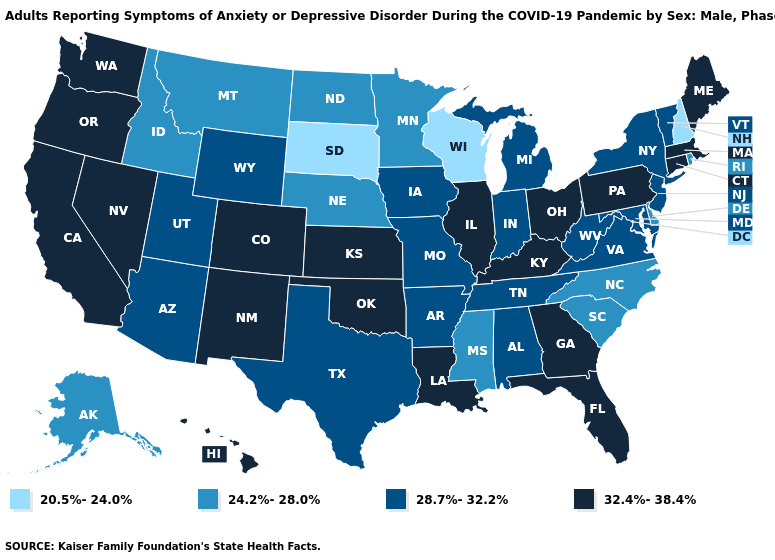Name the states that have a value in the range 20.5%-24.0%?
Short answer required. New Hampshire, South Dakota, Wisconsin. Is the legend a continuous bar?
Concise answer only. No. Name the states that have a value in the range 28.7%-32.2%?
Write a very short answer. Alabama, Arizona, Arkansas, Indiana, Iowa, Maryland, Michigan, Missouri, New Jersey, New York, Tennessee, Texas, Utah, Vermont, Virginia, West Virginia, Wyoming. Name the states that have a value in the range 32.4%-38.4%?
Quick response, please. California, Colorado, Connecticut, Florida, Georgia, Hawaii, Illinois, Kansas, Kentucky, Louisiana, Maine, Massachusetts, Nevada, New Mexico, Ohio, Oklahoma, Oregon, Pennsylvania, Washington. Which states have the lowest value in the USA?
Give a very brief answer. New Hampshire, South Dakota, Wisconsin. Among the states that border New Hampshire , does Vermont have the lowest value?
Give a very brief answer. Yes. What is the value of Mississippi?
Be succinct. 24.2%-28.0%. Among the states that border North Carolina , which have the highest value?
Be succinct. Georgia. Name the states that have a value in the range 28.7%-32.2%?
Answer briefly. Alabama, Arizona, Arkansas, Indiana, Iowa, Maryland, Michigan, Missouri, New Jersey, New York, Tennessee, Texas, Utah, Vermont, Virginia, West Virginia, Wyoming. Name the states that have a value in the range 32.4%-38.4%?
Write a very short answer. California, Colorado, Connecticut, Florida, Georgia, Hawaii, Illinois, Kansas, Kentucky, Louisiana, Maine, Massachusetts, Nevada, New Mexico, Ohio, Oklahoma, Oregon, Pennsylvania, Washington. What is the value of Michigan?
Concise answer only. 28.7%-32.2%. What is the value of Wisconsin?
Concise answer only. 20.5%-24.0%. How many symbols are there in the legend?
Answer briefly. 4. 